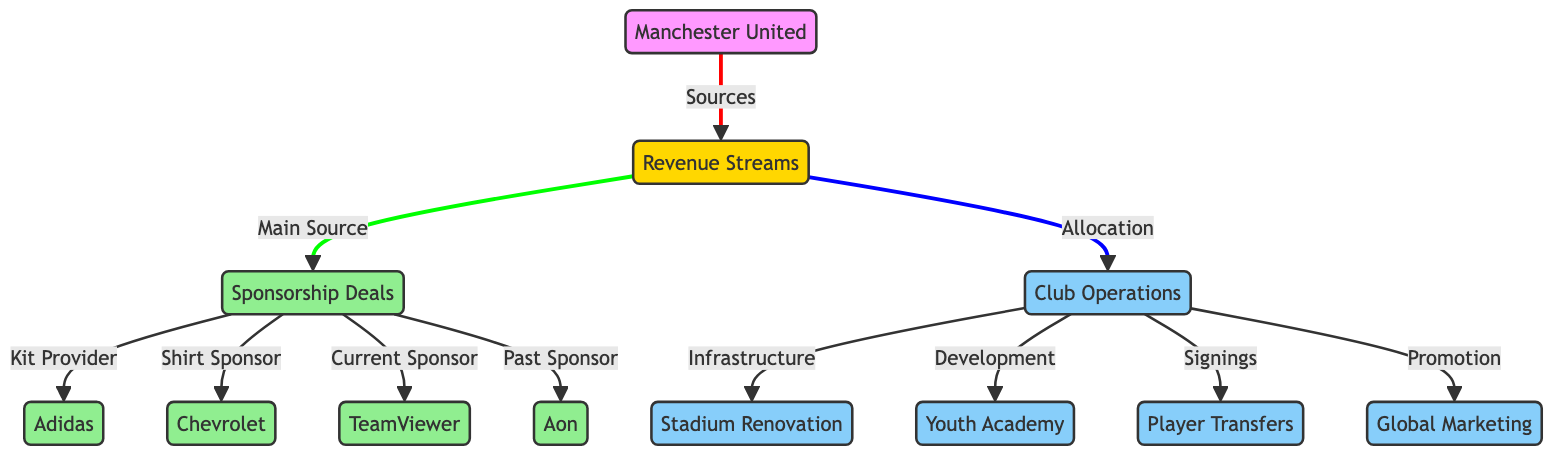What is the main source of revenue for Manchester United? The diagram indicates that the main source of revenue for Manchester United is labeled as "sponsorship." This is directly connecting the revenue streams to sponsorship deals.
Answer: sponsorship How many sponsorship deals are shown in the diagram? By reviewing the nodes connected to "sponsorship," there are four sponsorship deals indicated: Adidas, Chevrolet, TeamViewer, and Aon. Counting these nodes provides the total.
Answer: 4 Which company is the kit provider for Manchester United? The diagram specifies that Adidas is the "Kit Provider" under the sponsorship deals section. This relationship shows directly which company provides the kit.
Answer: Adidas What are two specific allocations of revenue to club operations? The diagram identifies several operations under "Club Operations." The two allocations that can be highlighted are "Stadium Renovation" and "Youth Academy." These are directly linked from revenue to operations.
Answer: Stadium Renovation, Youth Academy What does the sponsorship deal contribute to, according to the diagram? The sponsorship deals contribute primarily to the revenue streams of Manchester United, which are then allocated to club operations. The flow illustrates this connection clearly by linking sponsorship to revenue.
Answer: revenue streams What is the purpose of player transfers in club operations? Player transfers are categorized as "Signings" under club operations in the diagram. They serve as a financial operation for enhancing the team. The diagram outlines this category under operations.
Answer: Signings How many types of club operations are mentioned in the diagram? The diagram lists four operations: Stadium Renovation, Youth Academy, Player Transfers, and Global Marketing. Counting these nodes gives the total number of operations.
Answer: 4 Which sponsor is the current shirt sponsor according to the diagram? The diagram indicates that TeamViewer is the "Current Sponsor," directly addressing its role in the sponsorship structure of Manchester United.
Answer: TeamViewer What is the role of marketing in Manchester United's club operations? The diagram establishes that marketing is connected to club operations, specifically under the category "Promotion." This link explains the relevance of marketing in the overall operation strategy.
Answer: Promotion 